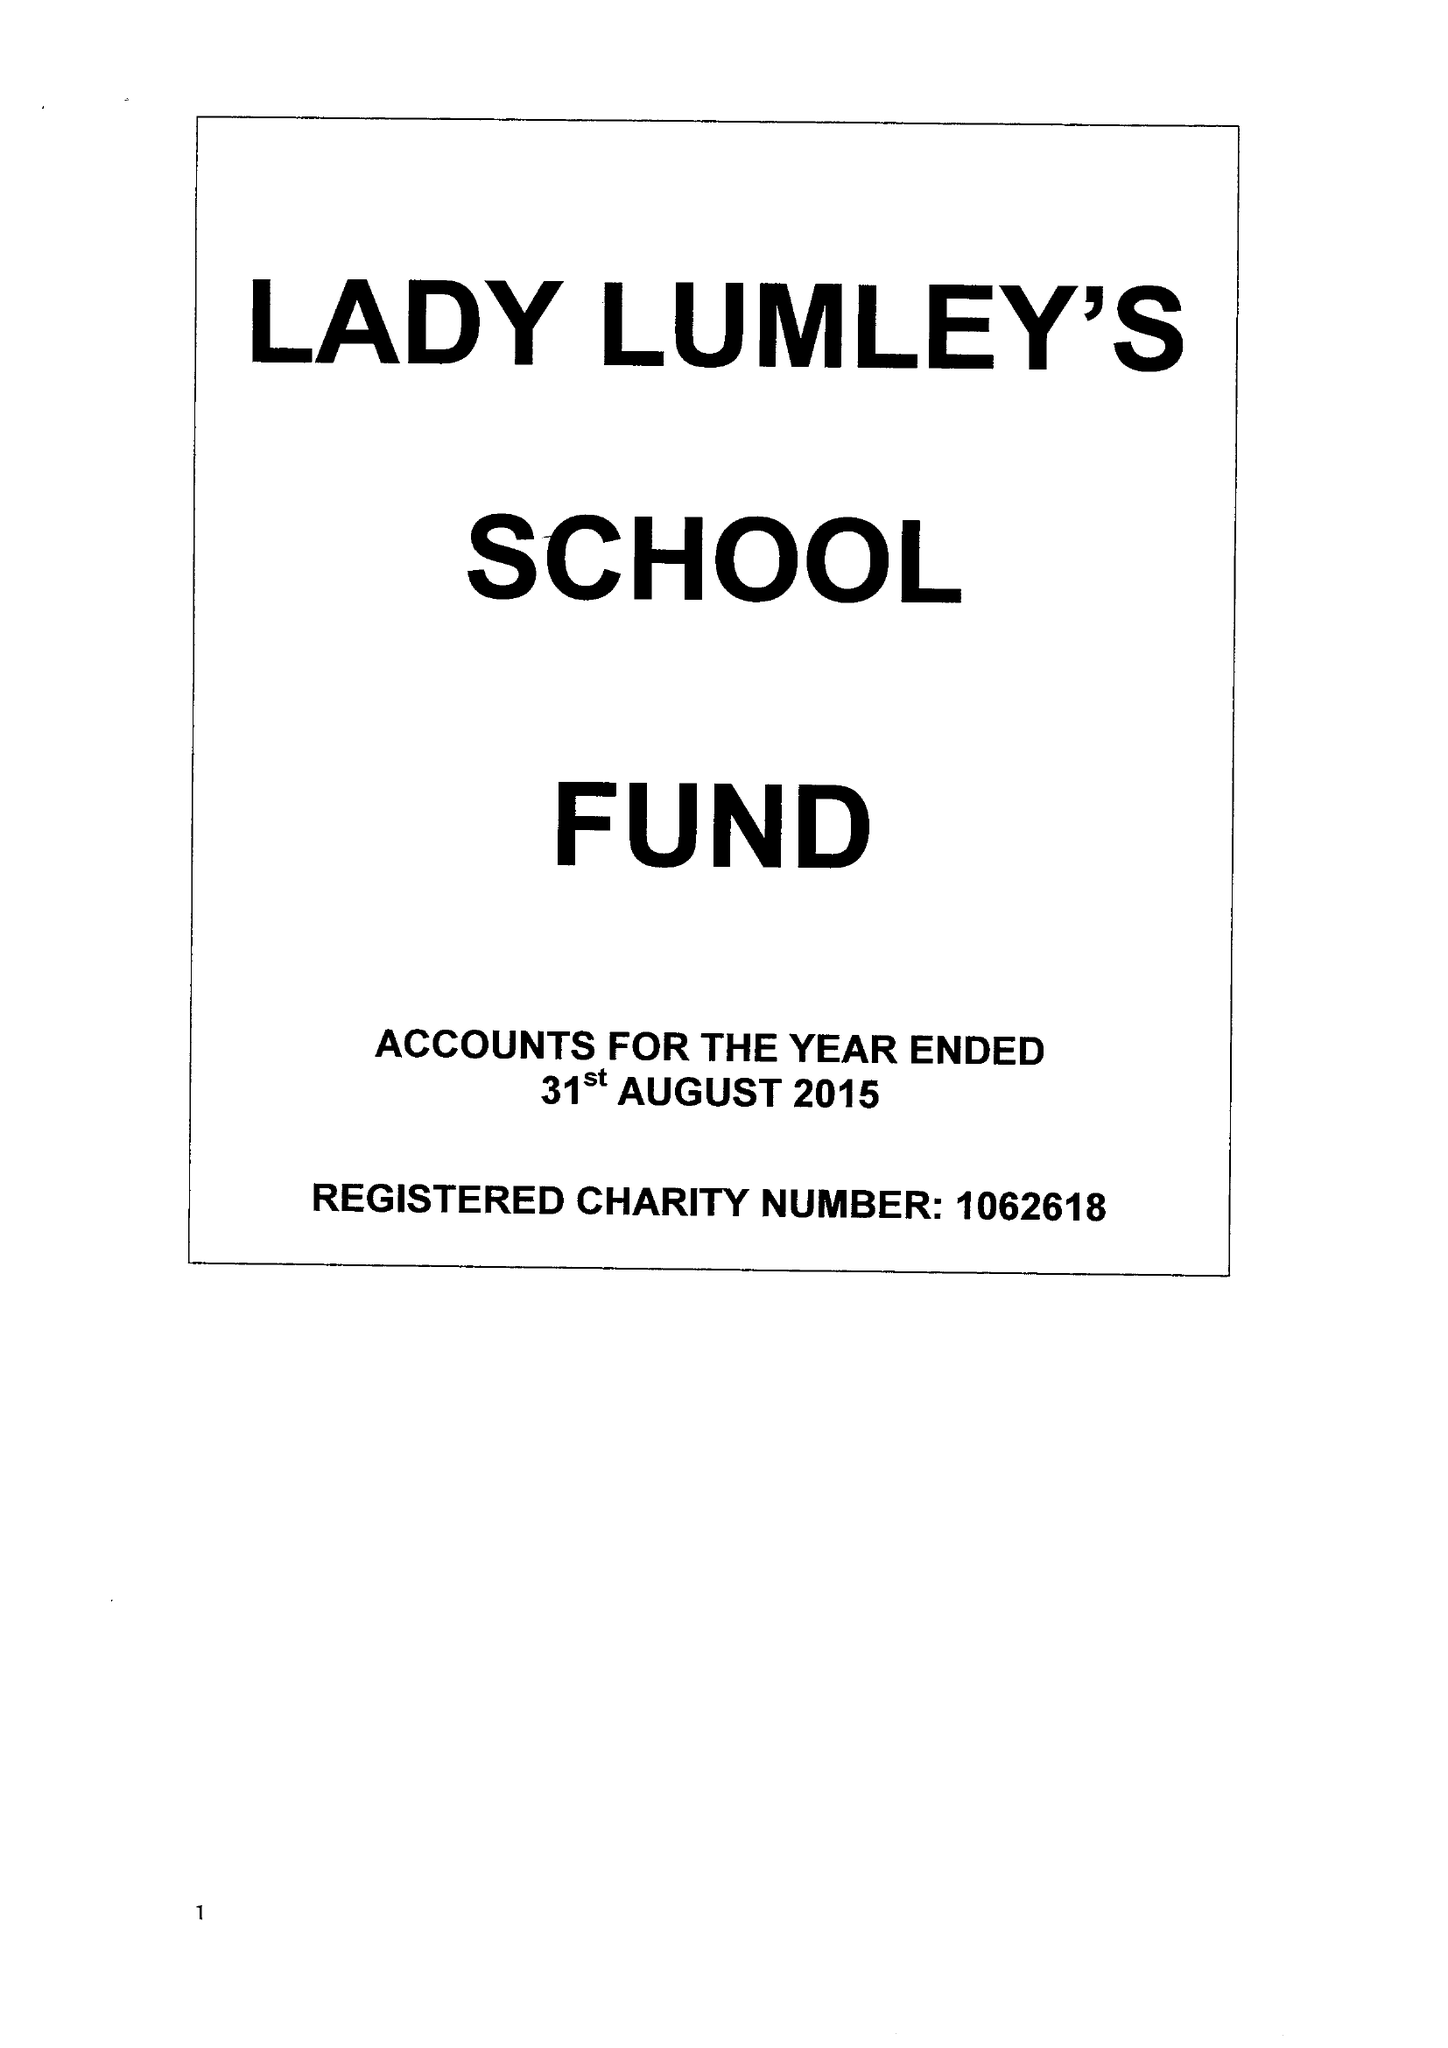What is the value for the address__postcode?
Answer the question using a single word or phrase. YO18 8NG 